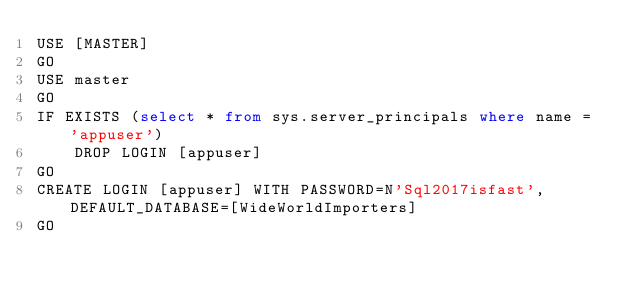<code> <loc_0><loc_0><loc_500><loc_500><_SQL_>USE [MASTER]
GO
USE master
GO
IF EXISTS (select * from sys.server_principals where name = 'appuser')
    DROP LOGIN [appuser]
GO
CREATE LOGIN [appuser] WITH PASSWORD=N'Sql2017isfast', DEFAULT_DATABASE=[WideWorldImporters]
GO
</code> 